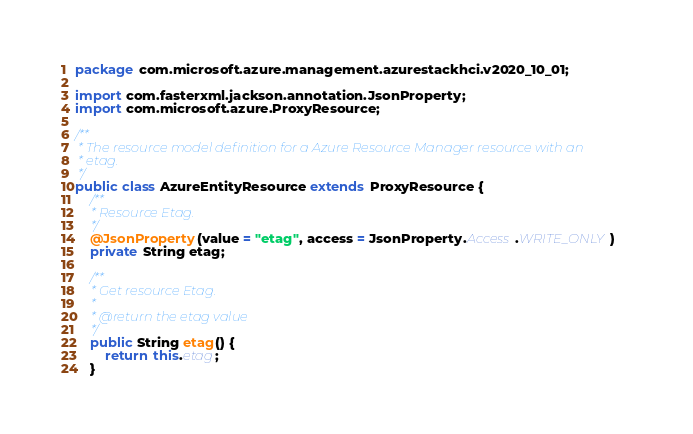Convert code to text. <code><loc_0><loc_0><loc_500><loc_500><_Java_>
package com.microsoft.azure.management.azurestackhci.v2020_10_01;

import com.fasterxml.jackson.annotation.JsonProperty;
import com.microsoft.azure.ProxyResource;

/**
 * The resource model definition for a Azure Resource Manager resource with an
 * etag.
 */
public class AzureEntityResource extends ProxyResource {
    /**
     * Resource Etag.
     */
    @JsonProperty(value = "etag", access = JsonProperty.Access.WRITE_ONLY)
    private String etag;

    /**
     * Get resource Etag.
     *
     * @return the etag value
     */
    public String etag() {
        return this.etag;
    }
</code> 